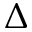<formula> <loc_0><loc_0><loc_500><loc_500>\Delta</formula> 